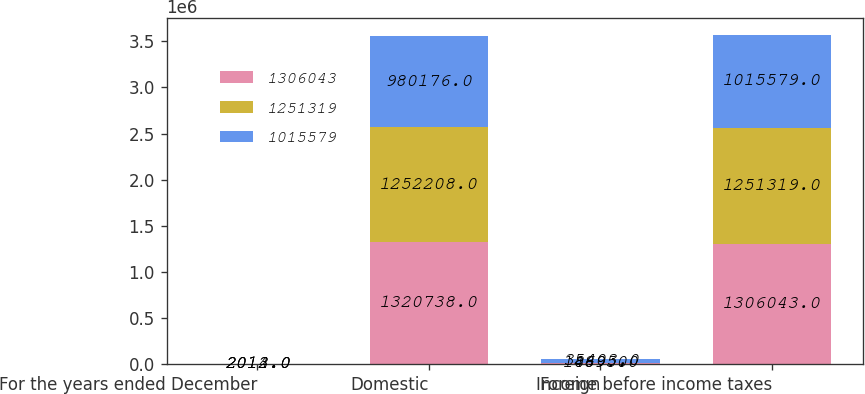Convert chart to OTSL. <chart><loc_0><loc_0><loc_500><loc_500><stacked_bar_chart><ecel><fcel>For the years ended December<fcel>Domestic<fcel>Foreign<fcel>Income before income taxes<nl><fcel>1.30604e+06<fcel>2014<fcel>1.32074e+06<fcel>14695<fcel>1.30604e+06<nl><fcel>1.25132e+06<fcel>2013<fcel>1.25221e+06<fcel>889<fcel>1.25132e+06<nl><fcel>1.01558e+06<fcel>2012<fcel>980176<fcel>35403<fcel>1.01558e+06<nl></chart> 